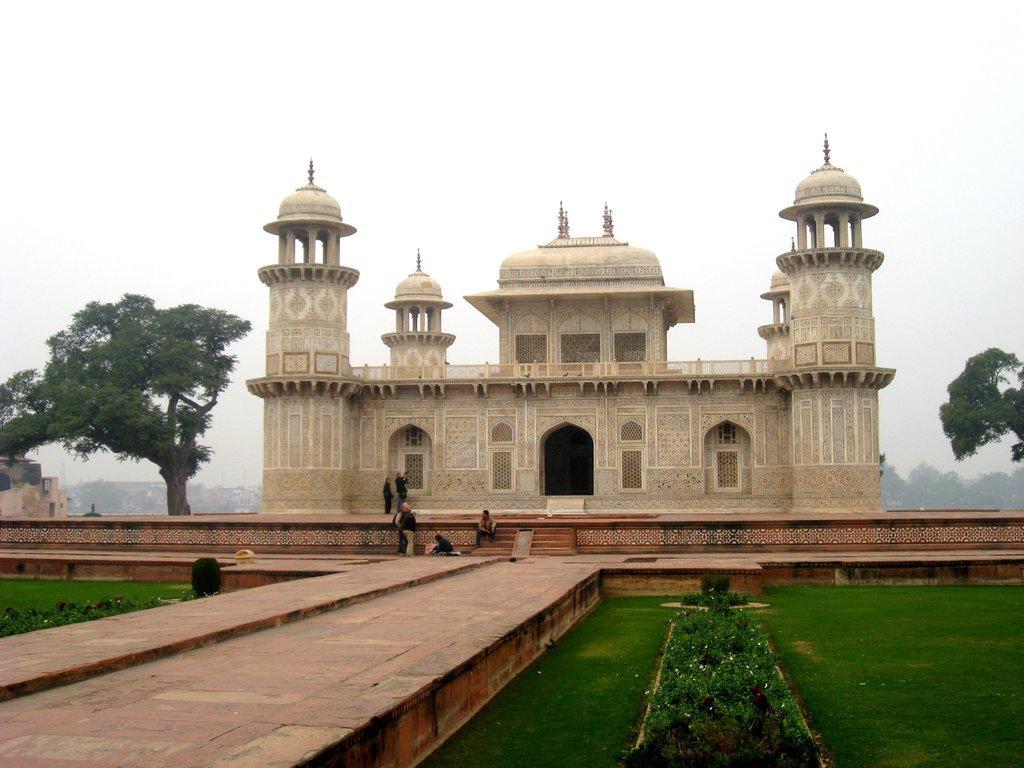Please provide a concise description of this image. In the image we can see a fort and the arch. There are even people standing and some of them are sitting, they are wearing clothes. Here we can see the footpath, grass, plants, trees and the sky. 